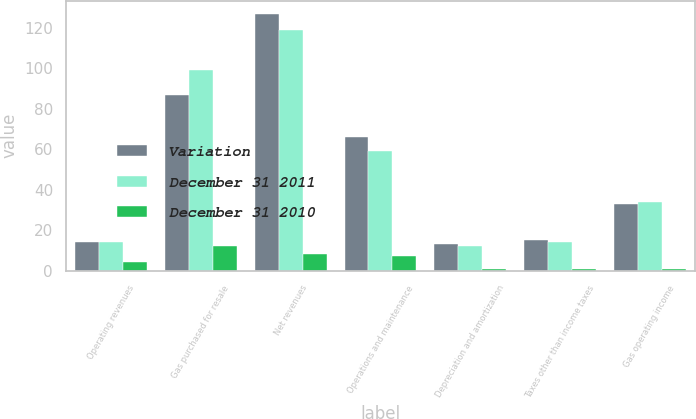<chart> <loc_0><loc_0><loc_500><loc_500><stacked_bar_chart><ecel><fcel>Operating revenues<fcel>Gas purchased for resale<fcel>Net revenues<fcel>Operations and maintenance<fcel>Depreciation and amortization<fcel>Taxes other than income taxes<fcel>Gas operating income<nl><fcel>Variation<fcel>14<fcel>87<fcel>127<fcel>66<fcel>13<fcel>15<fcel>33<nl><fcel>December 31 2011<fcel>14<fcel>99<fcel>119<fcel>59<fcel>12<fcel>14<fcel>34<nl><fcel>December 31 2010<fcel>4<fcel>12<fcel>8<fcel>7<fcel>1<fcel>1<fcel>1<nl></chart> 